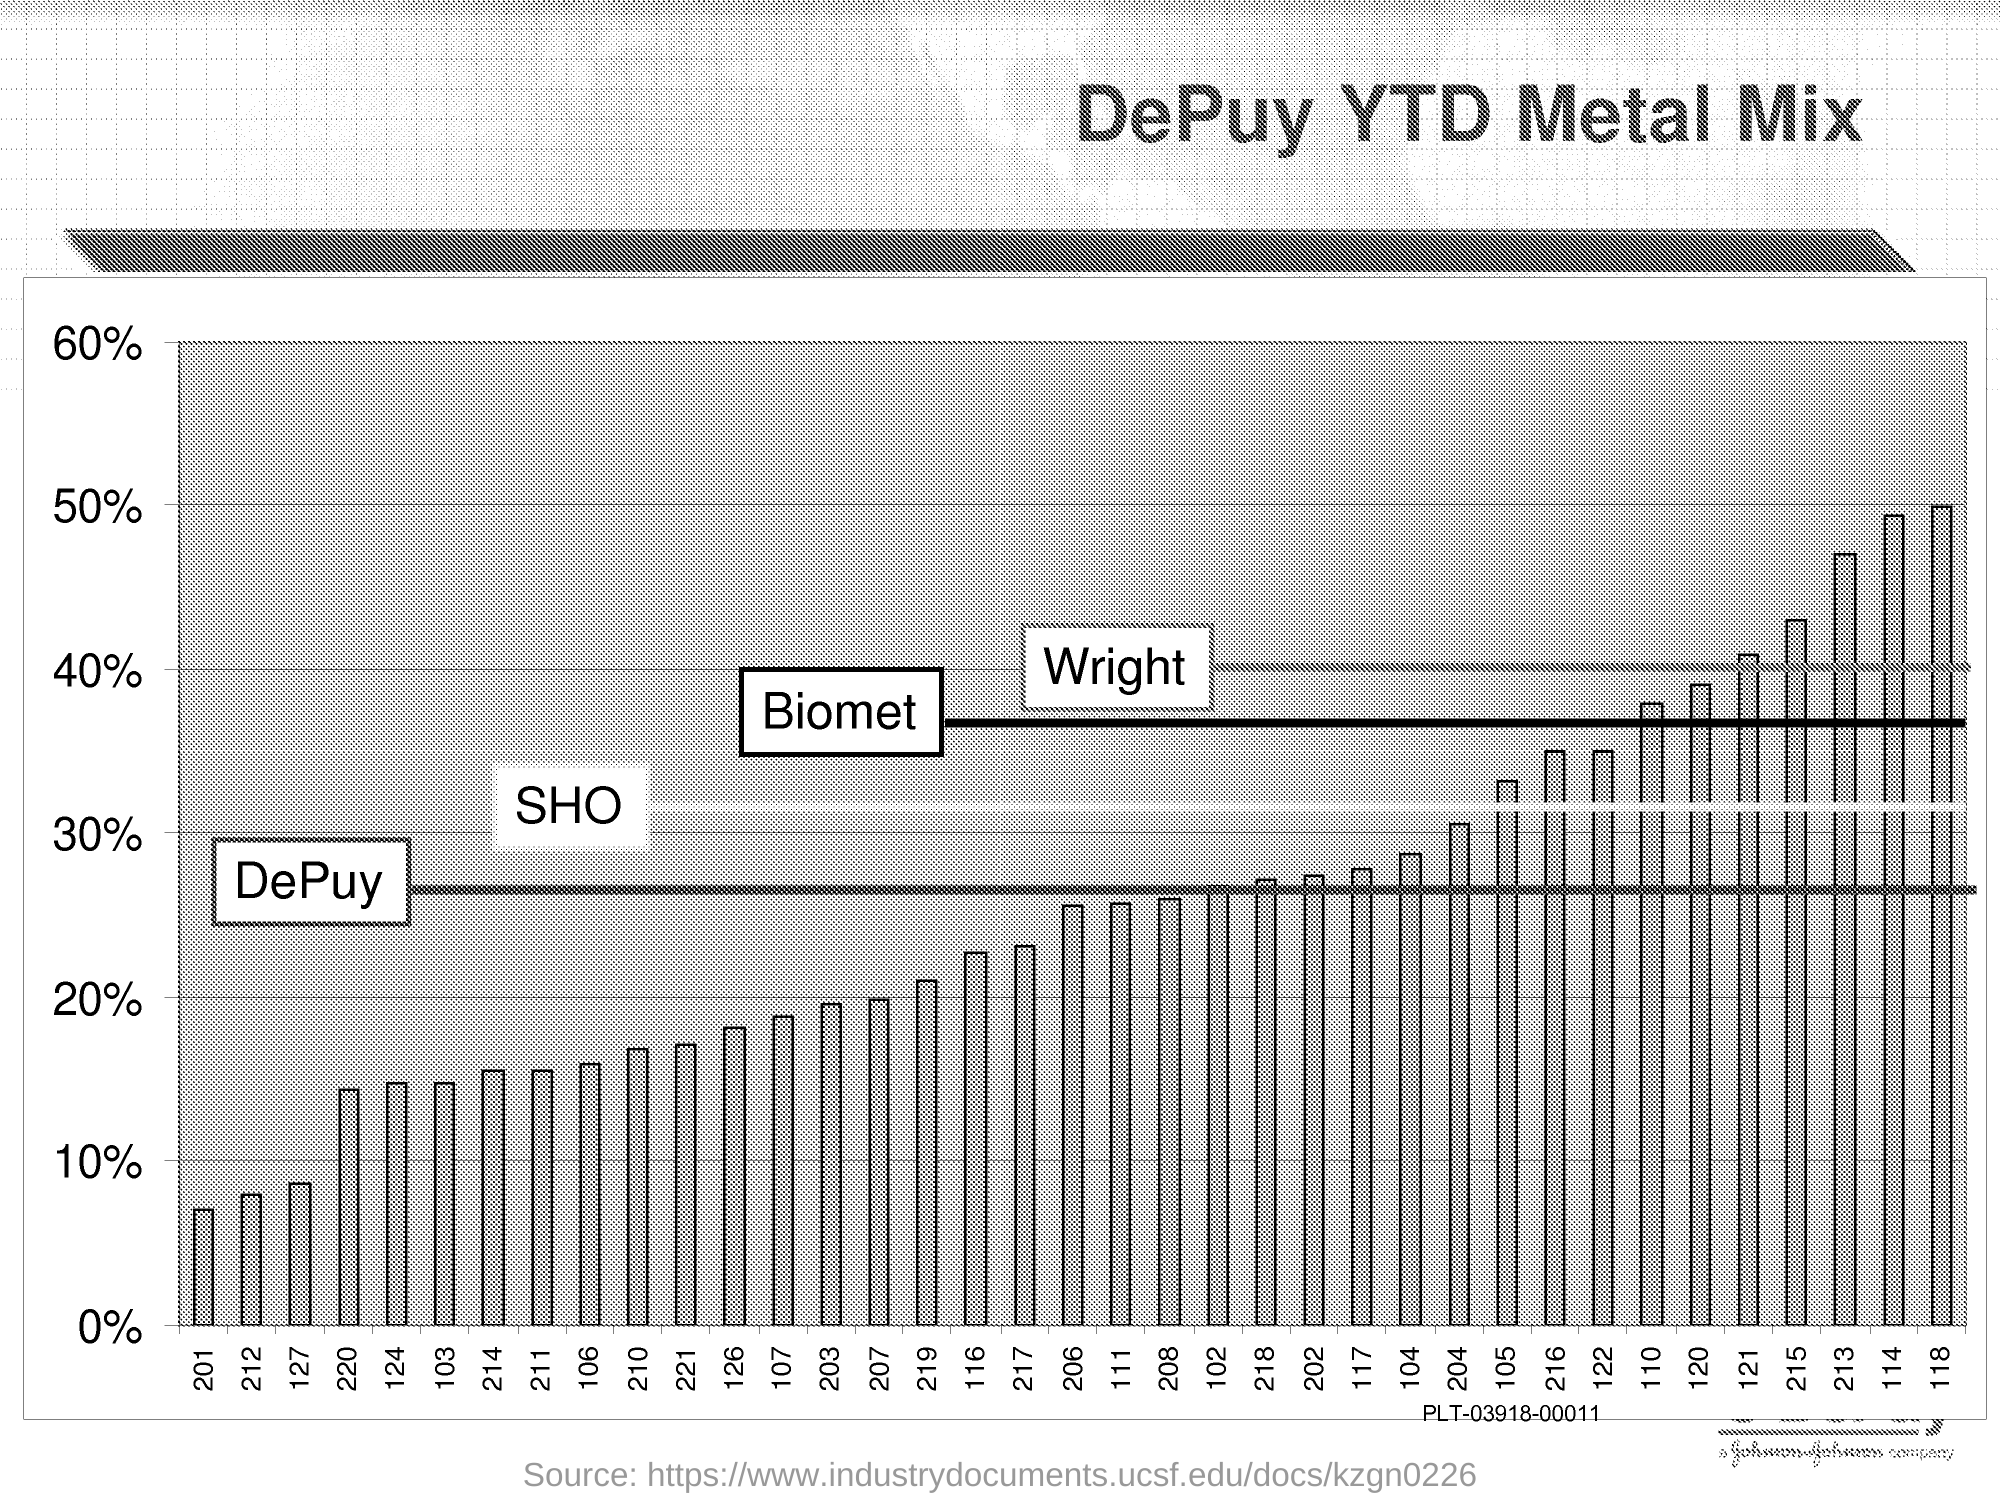List a handful of essential elements in this visual. This graph is titled 'DePuy YTD Metal Mix' and provides information on the performance of DePuy's year-to-date sales of metal hips. 